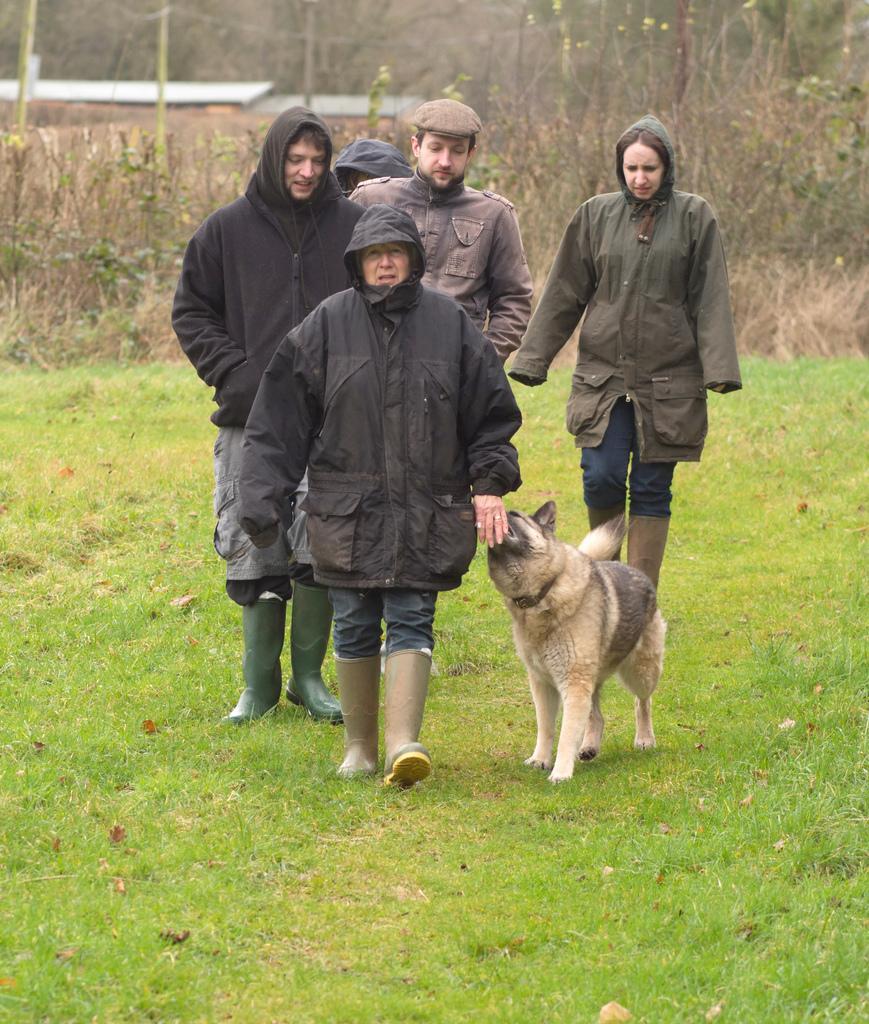Could you give a brief overview of what you see in this image? In this image we can see some persons and dog. In the background of the image there are plants, poles and other objects. At the bottom of the image there is the grass. 